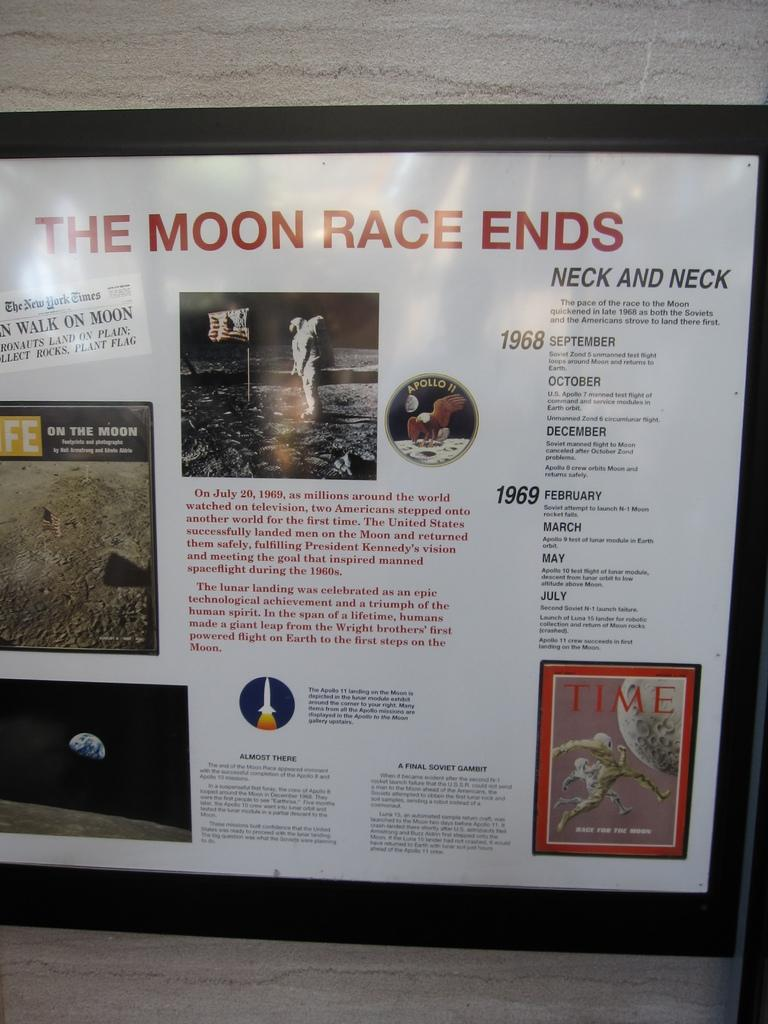Provide a one-sentence caption for the provided image. A poster with The moon race ends at to top of the poster. 